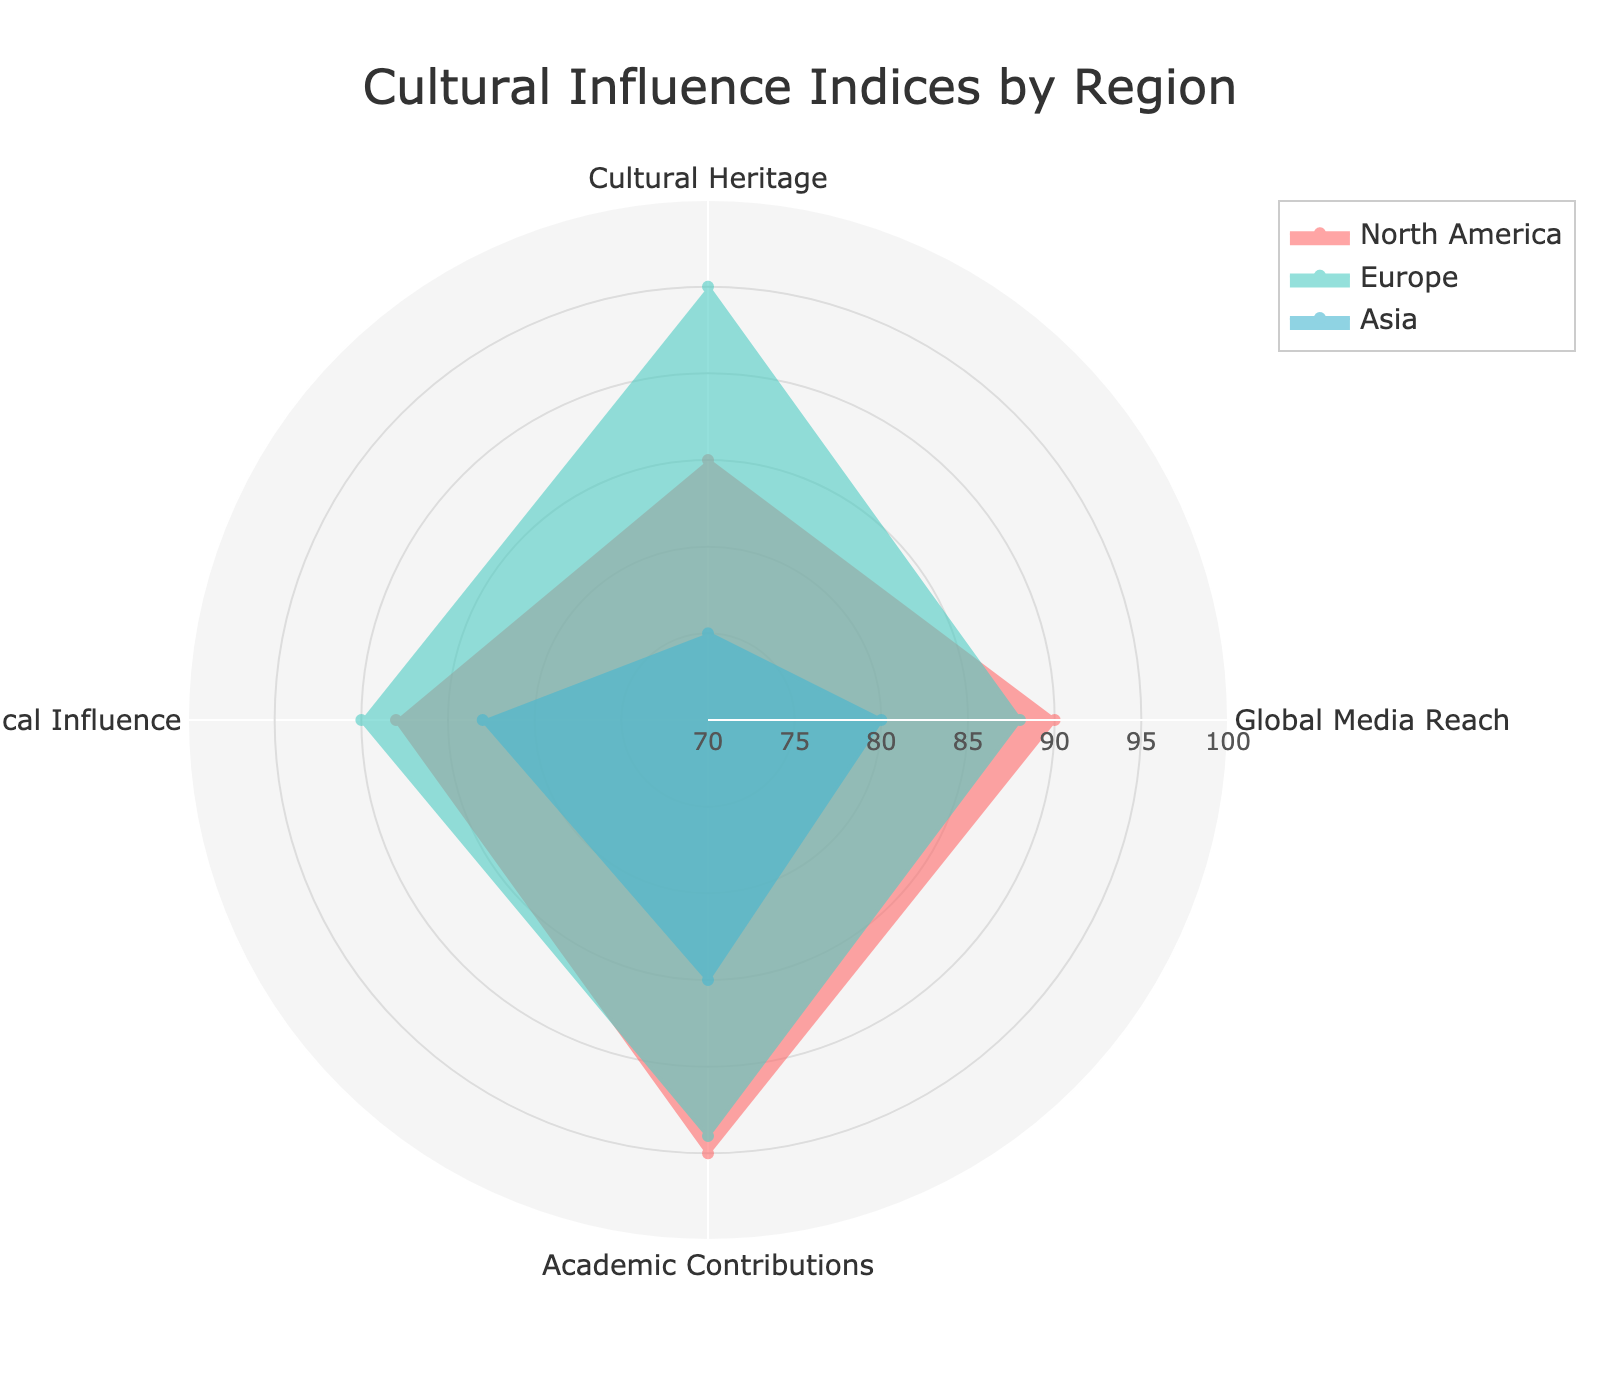Which region has the highest Political Influence score? By checking the radar chart, we compare the Political Influence scores for North America, Europe, and Asia. North America has a score of 88, Europe has 90, and Asia has 83.
Answer: Europe What is the title of the radar chart? The title is usually at the top center of the plot. From examining the data visualization and layout description, we can find the title.
Answer: Cultural Influence Indices by Region How many categories are used to evaluate the Cultural Influence? The categories in the radar chart correspond to the columns excluding the Region. These are Cultural Heritage, Global Media Reach, Academic Contributions, and Political Influence. There are four in total.
Answer: 4 Which region has the lowest Global Media Reach score, and what is the score? Comparing the Global Media Reach scores on the radar chart shows that North America scores 90, Europe scores 88, and Asia scores 80. Asia has the lowest with a score of 80.
Answer: Asia, 80 What is the difference in Academic Contributions scores between Europe and Asia? First, note the Academic Contributions scores from the plot: Europe has 94, and Asia has 85. The difference is calculated as 94 - 85.
Answer: 9 Which region displays the highest overall influence in the given categories? To determine the overall influence, we can visually compare the radar areas enclosed by each region's plot or sum the scores. Europe’s scores are generally the highest across categories.
Answer: Europe What is the range of the radial axis? According to the layout details of the radial axis, the range is set from 70 to 100.
Answer: 70-100 How does North America's Cultural Heritage score compare to its Political Influence score? Looking at North America’s scores in the radar chart, its Cultural Heritage score is 85, and its Political Influence score is 88. 88 is higher than 85.
Answer: Political Influence is higher What colors represent each region? The colors of the radar plot can be identified visually. North America is represented by a red-like color, Europe with a teal color, and Asia with a blue-like color.
Answer: North America: red-like, Europe: teal, Asia: blue-like Which category does Europe score highest in and what is the score? By examining Europe’s radar plot within the chart, the highest value is in Cultural Heritage with a score of 95.
Answer: Cultural Heritage, 95 